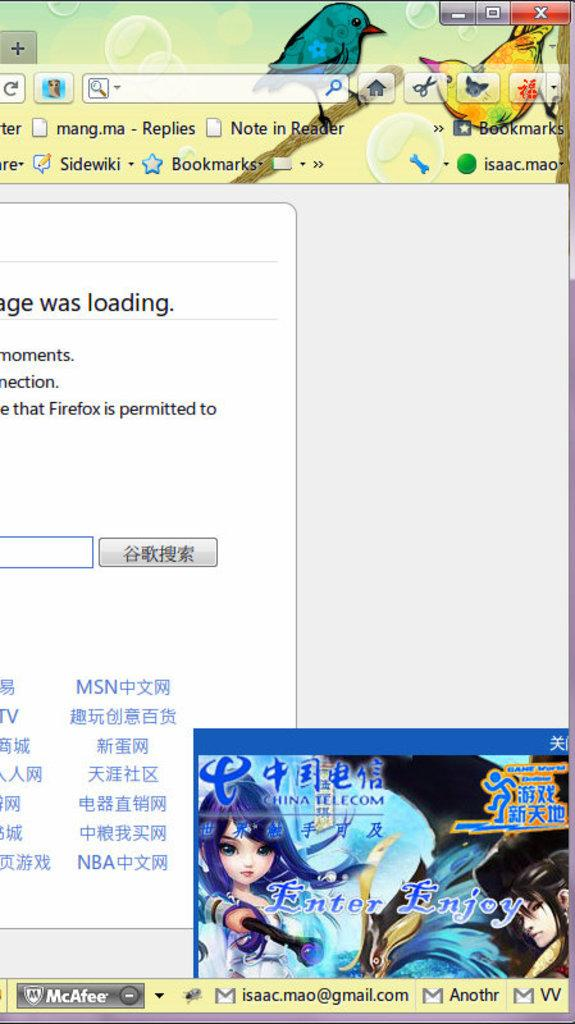What is the main subject of the image? The main subject of the image is a web page. What type of content can be found on the web page? The web page contains text and animated images. What type of protest is taking place in the image? There is no protest present in the image; it features a web page with text and animated images. What color is the scarf draped over the furniture in the image? There is no scarf or furniture present in the image; it features a web page with text and animated images. 